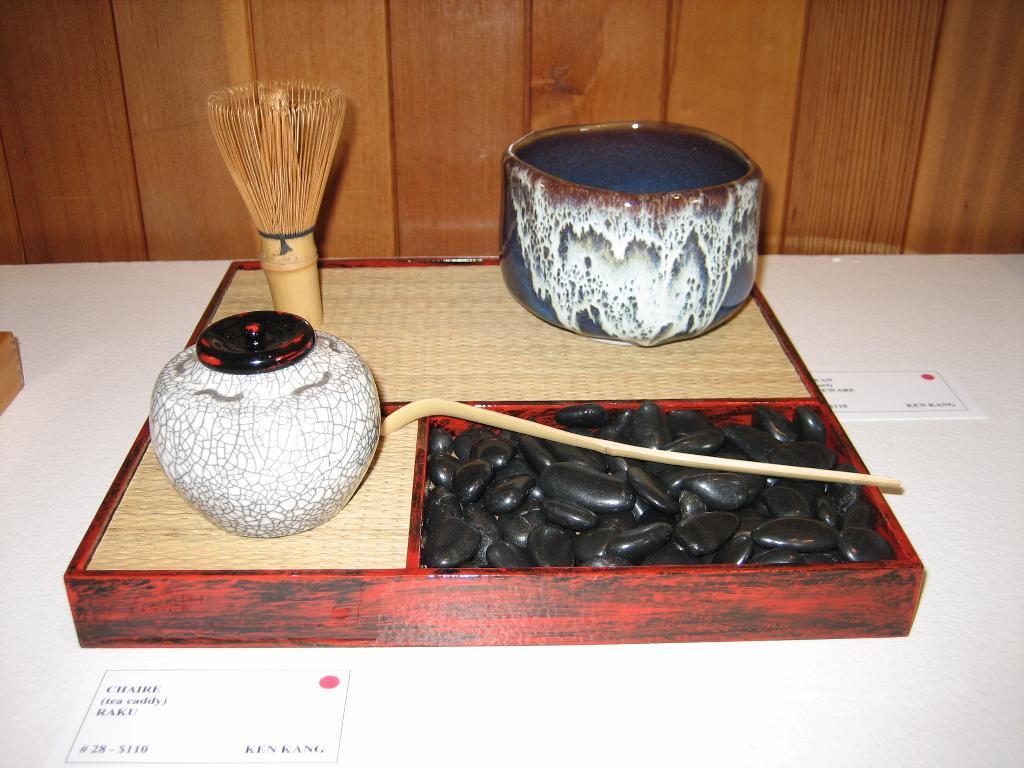Can you describe this image briefly? In this image there are some objects kept in a wooden box in the middle of this image and this box is kept on a white color floor. There is a wooden wall in the background. 